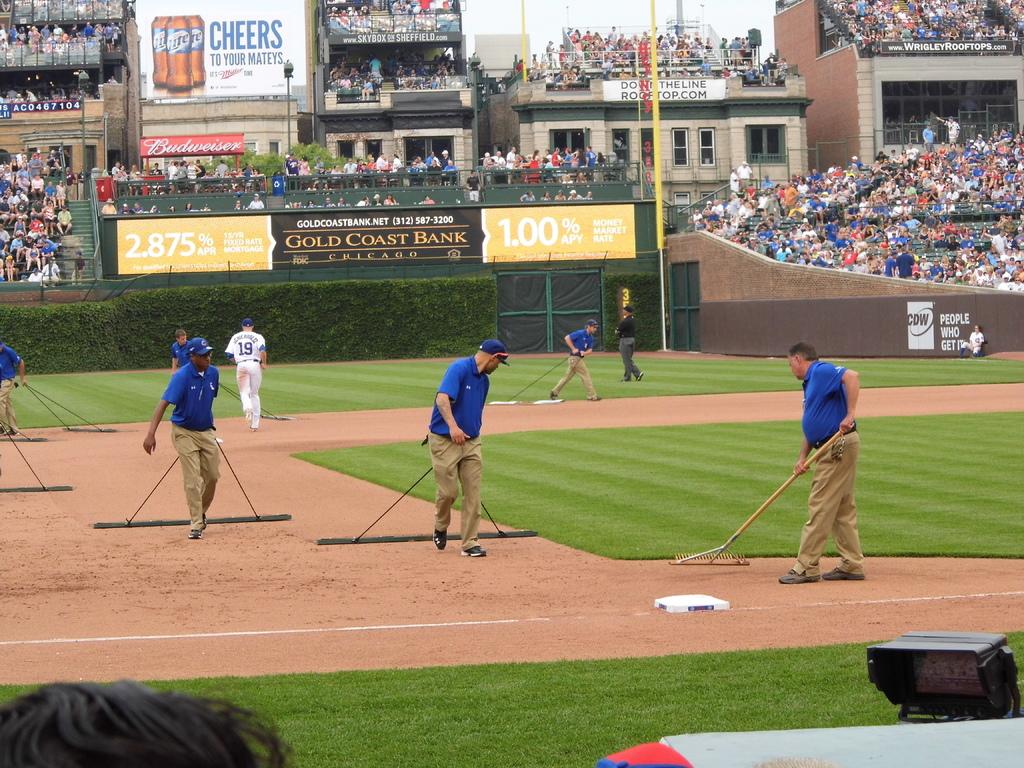What bank is mentioned?
Offer a terse response. Gold coast. Who are the people that get it?
Keep it short and to the point. Unanswerable. 